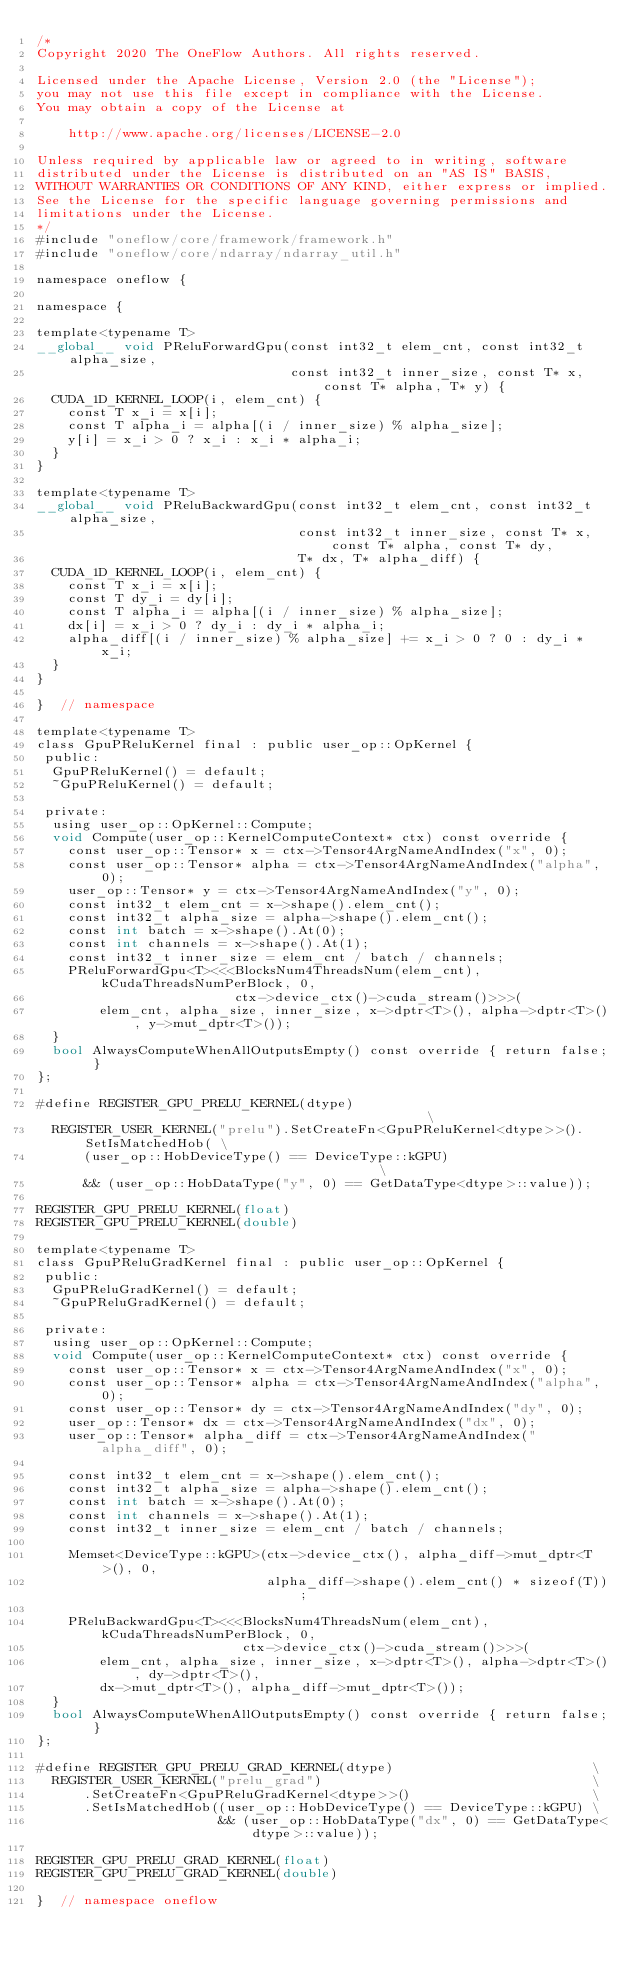Convert code to text. <code><loc_0><loc_0><loc_500><loc_500><_Cuda_>/*
Copyright 2020 The OneFlow Authors. All rights reserved.

Licensed under the Apache License, Version 2.0 (the "License");
you may not use this file except in compliance with the License.
You may obtain a copy of the License at

    http://www.apache.org/licenses/LICENSE-2.0

Unless required by applicable law or agreed to in writing, software
distributed under the License is distributed on an "AS IS" BASIS,
WITHOUT WARRANTIES OR CONDITIONS OF ANY KIND, either express or implied.
See the License for the specific language governing permissions and
limitations under the License.
*/
#include "oneflow/core/framework/framework.h"
#include "oneflow/core/ndarray/ndarray_util.h"

namespace oneflow {

namespace {

template<typename T>
__global__ void PReluForwardGpu(const int32_t elem_cnt, const int32_t alpha_size,
                                const int32_t inner_size, const T* x, const T* alpha, T* y) {
  CUDA_1D_KERNEL_LOOP(i, elem_cnt) {
    const T x_i = x[i];
    const T alpha_i = alpha[(i / inner_size) % alpha_size];
    y[i] = x_i > 0 ? x_i : x_i * alpha_i;
  }
}

template<typename T>
__global__ void PReluBackwardGpu(const int32_t elem_cnt, const int32_t alpha_size,
                                 const int32_t inner_size, const T* x, const T* alpha, const T* dy,
                                 T* dx, T* alpha_diff) {
  CUDA_1D_KERNEL_LOOP(i, elem_cnt) {
    const T x_i = x[i];
    const T dy_i = dy[i];
    const T alpha_i = alpha[(i / inner_size) % alpha_size];
    dx[i] = x_i > 0 ? dy_i : dy_i * alpha_i;
    alpha_diff[(i / inner_size) % alpha_size] += x_i > 0 ? 0 : dy_i * x_i;
  }
}

}  // namespace

template<typename T>
class GpuPReluKernel final : public user_op::OpKernel {
 public:
  GpuPReluKernel() = default;
  ~GpuPReluKernel() = default;

 private:
  using user_op::OpKernel::Compute;
  void Compute(user_op::KernelComputeContext* ctx) const override {
    const user_op::Tensor* x = ctx->Tensor4ArgNameAndIndex("x", 0);
    const user_op::Tensor* alpha = ctx->Tensor4ArgNameAndIndex("alpha", 0);
    user_op::Tensor* y = ctx->Tensor4ArgNameAndIndex("y", 0);
    const int32_t elem_cnt = x->shape().elem_cnt();
    const int32_t alpha_size = alpha->shape().elem_cnt();
    const int batch = x->shape().At(0);
    const int channels = x->shape().At(1);
    const int32_t inner_size = elem_cnt / batch / channels;
    PReluForwardGpu<T><<<BlocksNum4ThreadsNum(elem_cnt), kCudaThreadsNumPerBlock, 0,
                         ctx->device_ctx()->cuda_stream()>>>(
        elem_cnt, alpha_size, inner_size, x->dptr<T>(), alpha->dptr<T>(), y->mut_dptr<T>());
  }
  bool AlwaysComputeWhenAllOutputsEmpty() const override { return false; }
};

#define REGISTER_GPU_PRELU_KERNEL(dtype)                                              \
  REGISTER_USER_KERNEL("prelu").SetCreateFn<GpuPReluKernel<dtype>>().SetIsMatchedHob( \
      (user_op::HobDeviceType() == DeviceType::kGPU)                                  \
      && (user_op::HobDataType("y", 0) == GetDataType<dtype>::value));

REGISTER_GPU_PRELU_KERNEL(float)
REGISTER_GPU_PRELU_KERNEL(double)

template<typename T>
class GpuPReluGradKernel final : public user_op::OpKernel {
 public:
  GpuPReluGradKernel() = default;
  ~GpuPReluGradKernel() = default;

 private:
  using user_op::OpKernel::Compute;
  void Compute(user_op::KernelComputeContext* ctx) const override {
    const user_op::Tensor* x = ctx->Tensor4ArgNameAndIndex("x", 0);
    const user_op::Tensor* alpha = ctx->Tensor4ArgNameAndIndex("alpha", 0);
    const user_op::Tensor* dy = ctx->Tensor4ArgNameAndIndex("dy", 0);
    user_op::Tensor* dx = ctx->Tensor4ArgNameAndIndex("dx", 0);
    user_op::Tensor* alpha_diff = ctx->Tensor4ArgNameAndIndex("alpha_diff", 0);

    const int32_t elem_cnt = x->shape().elem_cnt();
    const int32_t alpha_size = alpha->shape().elem_cnt();
    const int batch = x->shape().At(0);
    const int channels = x->shape().At(1);
    const int32_t inner_size = elem_cnt / batch / channels;

    Memset<DeviceType::kGPU>(ctx->device_ctx(), alpha_diff->mut_dptr<T>(), 0,
                             alpha_diff->shape().elem_cnt() * sizeof(T));

    PReluBackwardGpu<T><<<BlocksNum4ThreadsNum(elem_cnt), kCudaThreadsNumPerBlock, 0,
                          ctx->device_ctx()->cuda_stream()>>>(
        elem_cnt, alpha_size, inner_size, x->dptr<T>(), alpha->dptr<T>(), dy->dptr<T>(),
        dx->mut_dptr<T>(), alpha_diff->mut_dptr<T>());
  }
  bool AlwaysComputeWhenAllOutputsEmpty() const override { return false; }
};

#define REGISTER_GPU_PRELU_GRAD_KERNEL(dtype)                         \
  REGISTER_USER_KERNEL("prelu_grad")                                  \
      .SetCreateFn<GpuPReluGradKernel<dtype>>()                       \
      .SetIsMatchedHob((user_op::HobDeviceType() == DeviceType::kGPU) \
                       && (user_op::HobDataType("dx", 0) == GetDataType<dtype>::value));

REGISTER_GPU_PRELU_GRAD_KERNEL(float)
REGISTER_GPU_PRELU_GRAD_KERNEL(double)

}  // namespace oneflow
</code> 